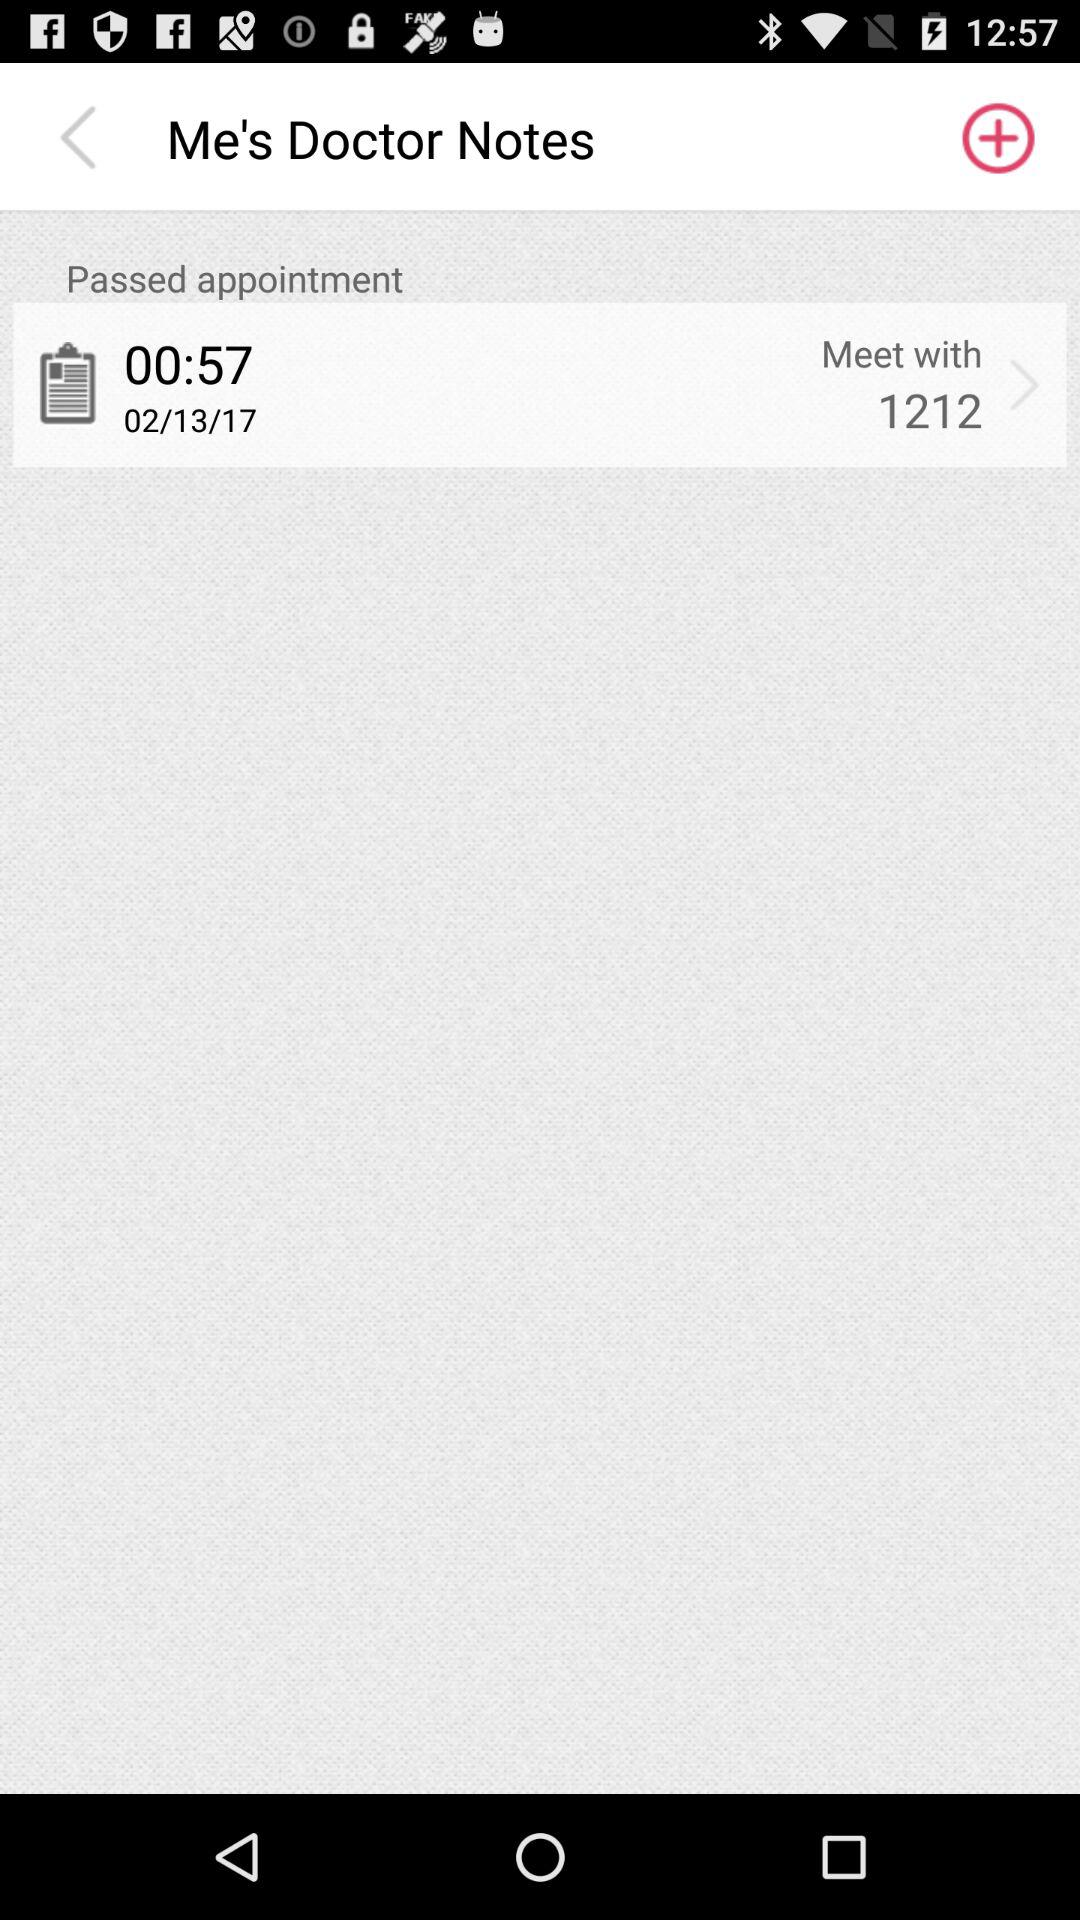What time is the appointment booked for? The appointment is booked for 00:57. 